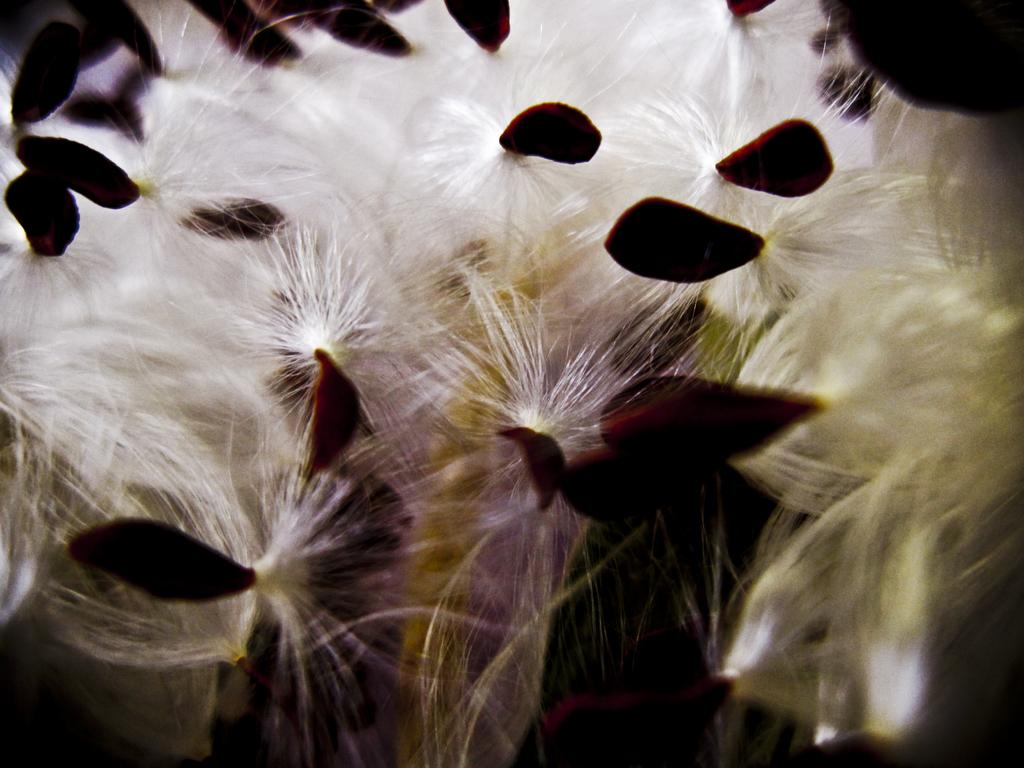How many birds can be seen in the image? There are no birds present in the image. What type of cub is visible in the image? There is no cub present in the image. How many people are in the crowd in the image? There is no crowd present in the image. 